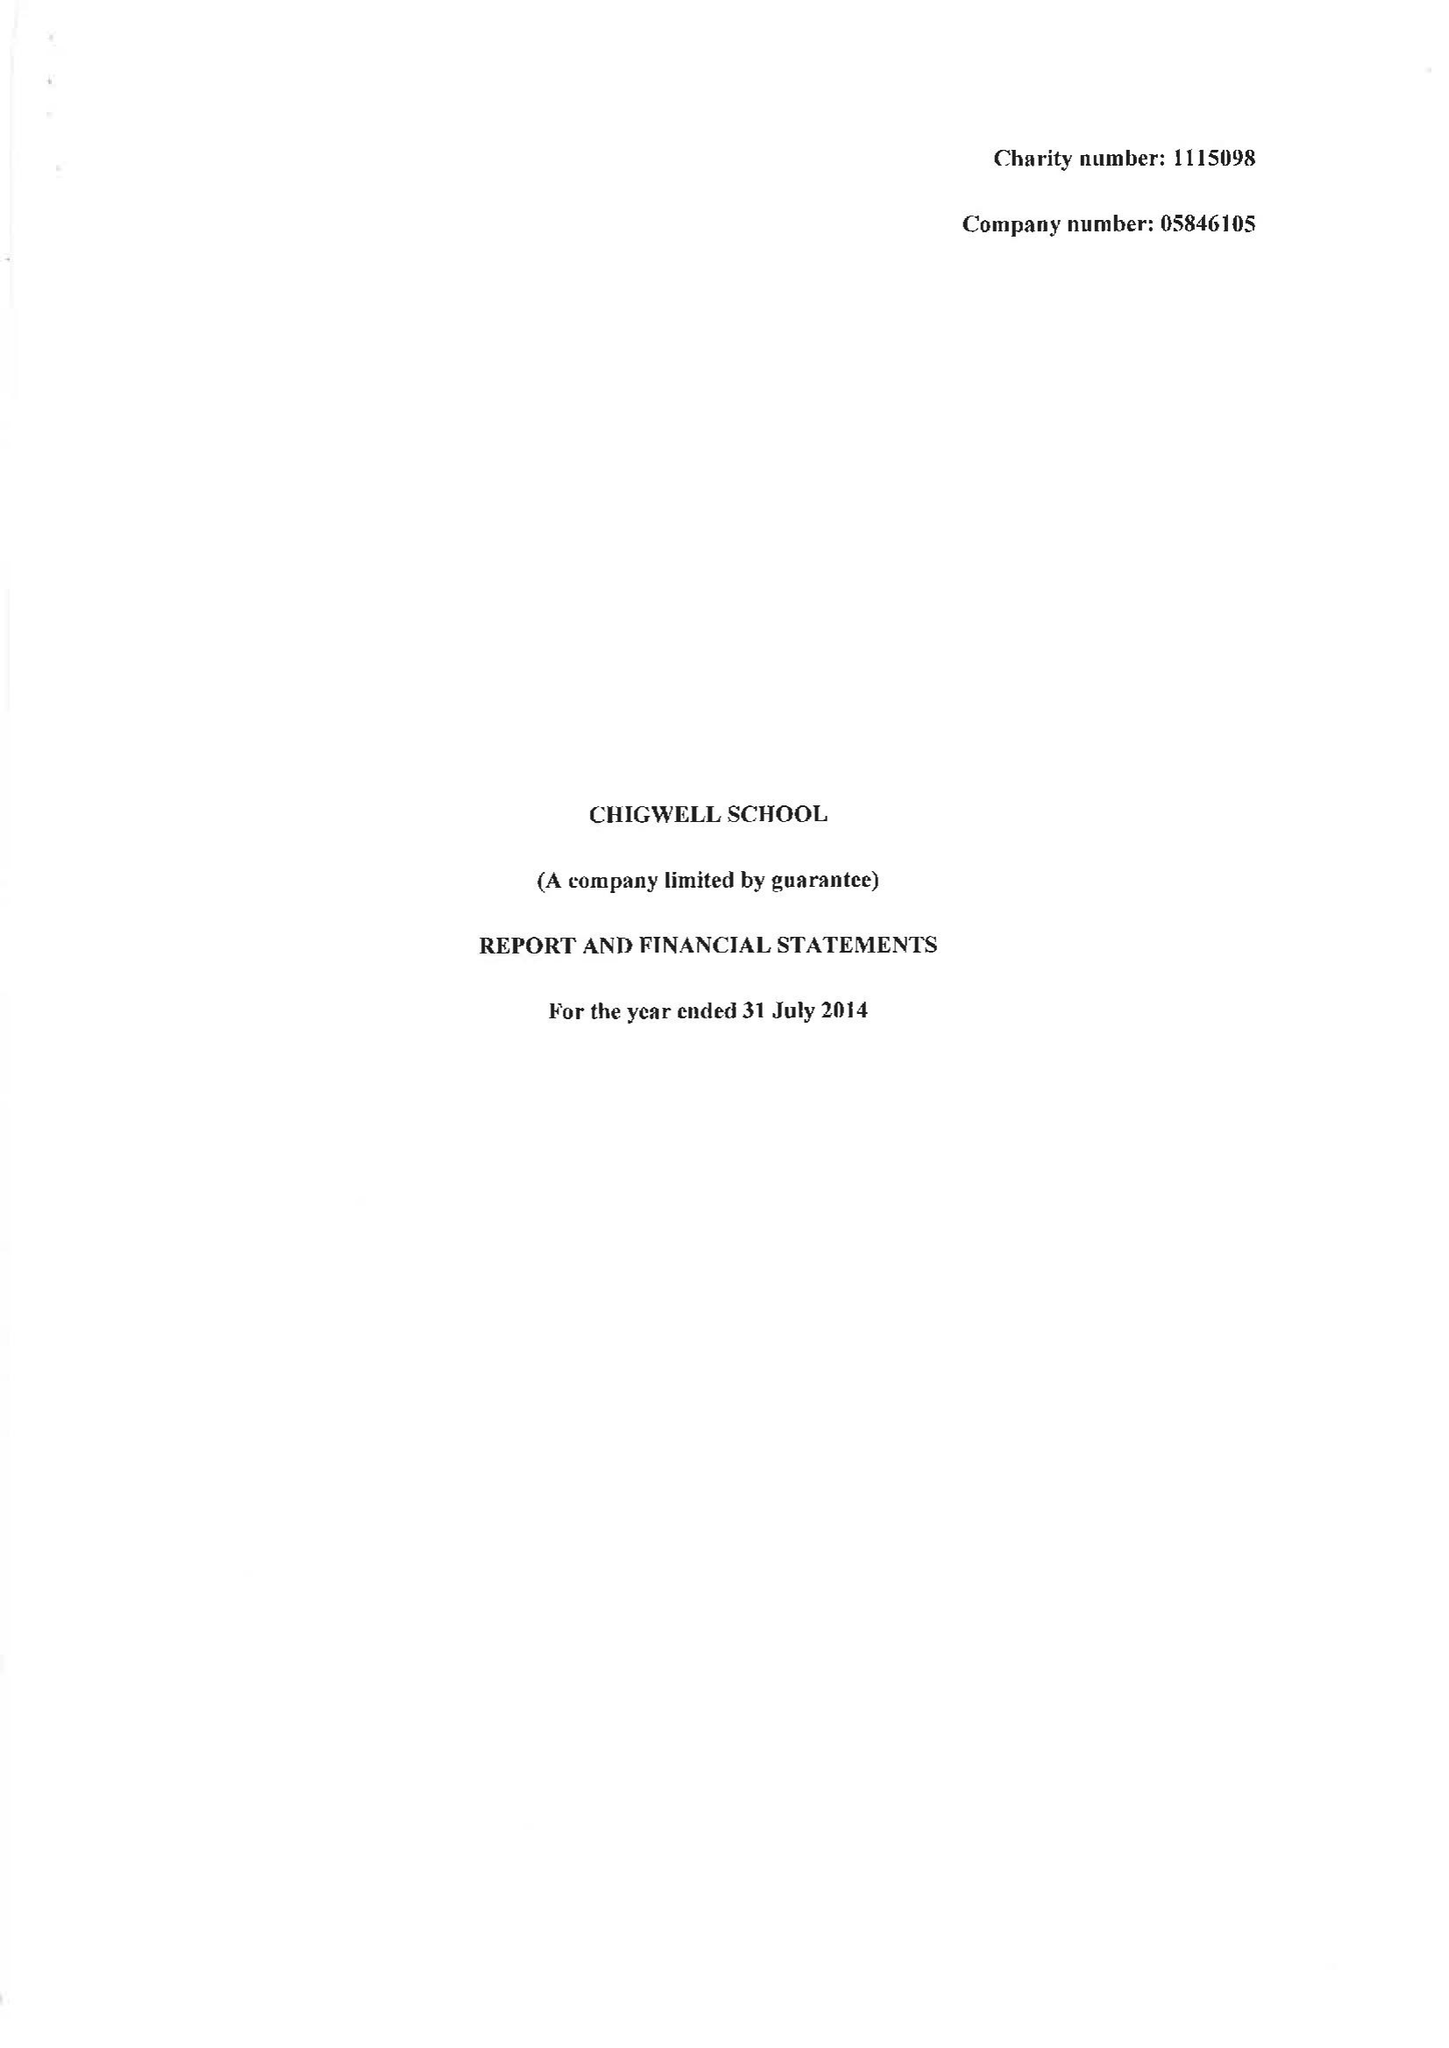What is the value for the spending_annually_in_british_pounds?
Answer the question using a single word or phrase. 10536000.00 